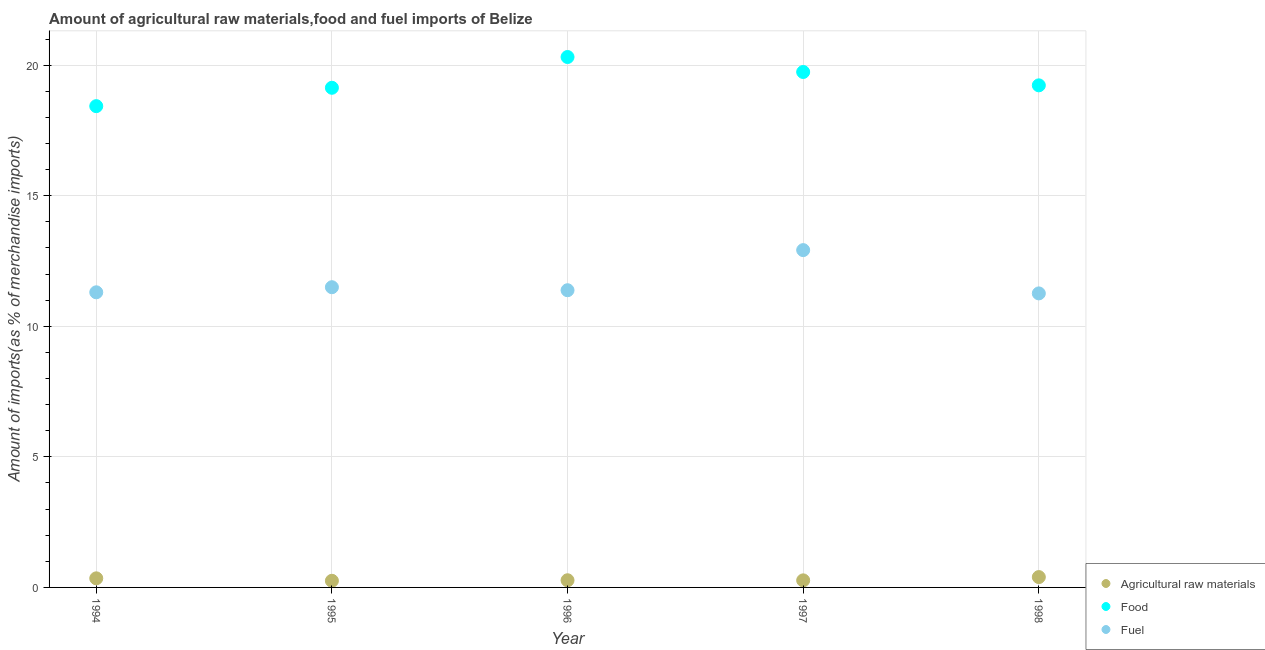What is the percentage of raw materials imports in 1998?
Offer a very short reply. 0.4. Across all years, what is the maximum percentage of food imports?
Provide a succinct answer. 20.31. Across all years, what is the minimum percentage of raw materials imports?
Your response must be concise. 0.25. In which year was the percentage of fuel imports maximum?
Your answer should be compact. 1997. What is the total percentage of fuel imports in the graph?
Your answer should be compact. 58.35. What is the difference between the percentage of food imports in 1995 and that in 1996?
Provide a short and direct response. -1.18. What is the difference between the percentage of food imports in 1994 and the percentage of fuel imports in 1995?
Your answer should be compact. 6.93. What is the average percentage of food imports per year?
Provide a short and direct response. 19.37. In the year 1998, what is the difference between the percentage of raw materials imports and percentage of food imports?
Make the answer very short. -18.83. In how many years, is the percentage of raw materials imports greater than 12 %?
Offer a very short reply. 0. What is the ratio of the percentage of fuel imports in 1996 to that in 1997?
Keep it short and to the point. 0.88. Is the percentage of raw materials imports in 1994 less than that in 1995?
Your answer should be compact. No. What is the difference between the highest and the second highest percentage of food imports?
Keep it short and to the point. 0.57. What is the difference between the highest and the lowest percentage of fuel imports?
Offer a terse response. 1.66. In how many years, is the percentage of fuel imports greater than the average percentage of fuel imports taken over all years?
Give a very brief answer. 1. Is the percentage of food imports strictly greater than the percentage of fuel imports over the years?
Your response must be concise. Yes. How many years are there in the graph?
Keep it short and to the point. 5. What is the difference between two consecutive major ticks on the Y-axis?
Ensure brevity in your answer.  5. Are the values on the major ticks of Y-axis written in scientific E-notation?
Your answer should be very brief. No. Does the graph contain any zero values?
Your answer should be very brief. No. Where does the legend appear in the graph?
Keep it short and to the point. Bottom right. How are the legend labels stacked?
Offer a terse response. Vertical. What is the title of the graph?
Make the answer very short. Amount of agricultural raw materials,food and fuel imports of Belize. What is the label or title of the X-axis?
Provide a short and direct response. Year. What is the label or title of the Y-axis?
Offer a terse response. Amount of imports(as % of merchandise imports). What is the Amount of imports(as % of merchandise imports) of Agricultural raw materials in 1994?
Offer a terse response. 0.35. What is the Amount of imports(as % of merchandise imports) of Food in 1994?
Your response must be concise. 18.43. What is the Amount of imports(as % of merchandise imports) in Fuel in 1994?
Your answer should be very brief. 11.3. What is the Amount of imports(as % of merchandise imports) of Agricultural raw materials in 1995?
Offer a very short reply. 0.25. What is the Amount of imports(as % of merchandise imports) in Food in 1995?
Give a very brief answer. 19.13. What is the Amount of imports(as % of merchandise imports) in Fuel in 1995?
Ensure brevity in your answer.  11.5. What is the Amount of imports(as % of merchandise imports) of Agricultural raw materials in 1996?
Offer a very short reply. 0.27. What is the Amount of imports(as % of merchandise imports) in Food in 1996?
Your response must be concise. 20.31. What is the Amount of imports(as % of merchandise imports) of Fuel in 1996?
Offer a very short reply. 11.38. What is the Amount of imports(as % of merchandise imports) of Agricultural raw materials in 1997?
Your answer should be very brief. 0.27. What is the Amount of imports(as % of merchandise imports) of Food in 1997?
Your answer should be very brief. 19.74. What is the Amount of imports(as % of merchandise imports) of Fuel in 1997?
Offer a very short reply. 12.92. What is the Amount of imports(as % of merchandise imports) in Agricultural raw materials in 1998?
Give a very brief answer. 0.4. What is the Amount of imports(as % of merchandise imports) in Food in 1998?
Your response must be concise. 19.23. What is the Amount of imports(as % of merchandise imports) of Fuel in 1998?
Make the answer very short. 11.26. Across all years, what is the maximum Amount of imports(as % of merchandise imports) of Agricultural raw materials?
Provide a short and direct response. 0.4. Across all years, what is the maximum Amount of imports(as % of merchandise imports) in Food?
Give a very brief answer. 20.31. Across all years, what is the maximum Amount of imports(as % of merchandise imports) of Fuel?
Offer a terse response. 12.92. Across all years, what is the minimum Amount of imports(as % of merchandise imports) in Agricultural raw materials?
Give a very brief answer. 0.25. Across all years, what is the minimum Amount of imports(as % of merchandise imports) in Food?
Keep it short and to the point. 18.43. Across all years, what is the minimum Amount of imports(as % of merchandise imports) in Fuel?
Offer a terse response. 11.26. What is the total Amount of imports(as % of merchandise imports) of Agricultural raw materials in the graph?
Provide a succinct answer. 1.54. What is the total Amount of imports(as % of merchandise imports) in Food in the graph?
Make the answer very short. 96.84. What is the total Amount of imports(as % of merchandise imports) in Fuel in the graph?
Your answer should be very brief. 58.35. What is the difference between the Amount of imports(as % of merchandise imports) of Agricultural raw materials in 1994 and that in 1995?
Keep it short and to the point. 0.09. What is the difference between the Amount of imports(as % of merchandise imports) of Food in 1994 and that in 1995?
Keep it short and to the point. -0.7. What is the difference between the Amount of imports(as % of merchandise imports) in Fuel in 1994 and that in 1995?
Make the answer very short. -0.19. What is the difference between the Amount of imports(as % of merchandise imports) of Agricultural raw materials in 1994 and that in 1996?
Your answer should be very brief. 0.07. What is the difference between the Amount of imports(as % of merchandise imports) of Food in 1994 and that in 1996?
Keep it short and to the point. -1.88. What is the difference between the Amount of imports(as % of merchandise imports) of Fuel in 1994 and that in 1996?
Make the answer very short. -0.08. What is the difference between the Amount of imports(as % of merchandise imports) of Agricultural raw materials in 1994 and that in 1997?
Keep it short and to the point. 0.08. What is the difference between the Amount of imports(as % of merchandise imports) in Food in 1994 and that in 1997?
Keep it short and to the point. -1.31. What is the difference between the Amount of imports(as % of merchandise imports) of Fuel in 1994 and that in 1997?
Provide a short and direct response. -1.62. What is the difference between the Amount of imports(as % of merchandise imports) of Agricultural raw materials in 1994 and that in 1998?
Provide a short and direct response. -0.05. What is the difference between the Amount of imports(as % of merchandise imports) of Food in 1994 and that in 1998?
Your response must be concise. -0.8. What is the difference between the Amount of imports(as % of merchandise imports) of Fuel in 1994 and that in 1998?
Offer a terse response. 0.04. What is the difference between the Amount of imports(as % of merchandise imports) of Agricultural raw materials in 1995 and that in 1996?
Your answer should be very brief. -0.02. What is the difference between the Amount of imports(as % of merchandise imports) of Food in 1995 and that in 1996?
Keep it short and to the point. -1.18. What is the difference between the Amount of imports(as % of merchandise imports) in Fuel in 1995 and that in 1996?
Keep it short and to the point. 0.12. What is the difference between the Amount of imports(as % of merchandise imports) in Agricultural raw materials in 1995 and that in 1997?
Offer a terse response. -0.02. What is the difference between the Amount of imports(as % of merchandise imports) of Food in 1995 and that in 1997?
Your answer should be compact. -0.6. What is the difference between the Amount of imports(as % of merchandise imports) in Fuel in 1995 and that in 1997?
Provide a short and direct response. -1.42. What is the difference between the Amount of imports(as % of merchandise imports) of Agricultural raw materials in 1995 and that in 1998?
Provide a succinct answer. -0.14. What is the difference between the Amount of imports(as % of merchandise imports) in Food in 1995 and that in 1998?
Your answer should be very brief. -0.09. What is the difference between the Amount of imports(as % of merchandise imports) of Fuel in 1995 and that in 1998?
Ensure brevity in your answer.  0.24. What is the difference between the Amount of imports(as % of merchandise imports) in Agricultural raw materials in 1996 and that in 1997?
Provide a short and direct response. 0. What is the difference between the Amount of imports(as % of merchandise imports) in Food in 1996 and that in 1997?
Your response must be concise. 0.57. What is the difference between the Amount of imports(as % of merchandise imports) in Fuel in 1996 and that in 1997?
Provide a short and direct response. -1.54. What is the difference between the Amount of imports(as % of merchandise imports) of Agricultural raw materials in 1996 and that in 1998?
Ensure brevity in your answer.  -0.12. What is the difference between the Amount of imports(as % of merchandise imports) in Food in 1996 and that in 1998?
Ensure brevity in your answer.  1.08. What is the difference between the Amount of imports(as % of merchandise imports) in Fuel in 1996 and that in 1998?
Ensure brevity in your answer.  0.12. What is the difference between the Amount of imports(as % of merchandise imports) in Agricultural raw materials in 1997 and that in 1998?
Keep it short and to the point. -0.13. What is the difference between the Amount of imports(as % of merchandise imports) in Food in 1997 and that in 1998?
Offer a terse response. 0.51. What is the difference between the Amount of imports(as % of merchandise imports) in Fuel in 1997 and that in 1998?
Make the answer very short. 1.66. What is the difference between the Amount of imports(as % of merchandise imports) in Agricultural raw materials in 1994 and the Amount of imports(as % of merchandise imports) in Food in 1995?
Keep it short and to the point. -18.79. What is the difference between the Amount of imports(as % of merchandise imports) in Agricultural raw materials in 1994 and the Amount of imports(as % of merchandise imports) in Fuel in 1995?
Offer a very short reply. -11.15. What is the difference between the Amount of imports(as % of merchandise imports) in Food in 1994 and the Amount of imports(as % of merchandise imports) in Fuel in 1995?
Your answer should be very brief. 6.93. What is the difference between the Amount of imports(as % of merchandise imports) of Agricultural raw materials in 1994 and the Amount of imports(as % of merchandise imports) of Food in 1996?
Give a very brief answer. -19.96. What is the difference between the Amount of imports(as % of merchandise imports) in Agricultural raw materials in 1994 and the Amount of imports(as % of merchandise imports) in Fuel in 1996?
Provide a succinct answer. -11.03. What is the difference between the Amount of imports(as % of merchandise imports) of Food in 1994 and the Amount of imports(as % of merchandise imports) of Fuel in 1996?
Ensure brevity in your answer.  7.05. What is the difference between the Amount of imports(as % of merchandise imports) in Agricultural raw materials in 1994 and the Amount of imports(as % of merchandise imports) in Food in 1997?
Your answer should be compact. -19.39. What is the difference between the Amount of imports(as % of merchandise imports) of Agricultural raw materials in 1994 and the Amount of imports(as % of merchandise imports) of Fuel in 1997?
Offer a terse response. -12.57. What is the difference between the Amount of imports(as % of merchandise imports) in Food in 1994 and the Amount of imports(as % of merchandise imports) in Fuel in 1997?
Provide a succinct answer. 5.51. What is the difference between the Amount of imports(as % of merchandise imports) in Agricultural raw materials in 1994 and the Amount of imports(as % of merchandise imports) in Food in 1998?
Offer a very short reply. -18.88. What is the difference between the Amount of imports(as % of merchandise imports) of Agricultural raw materials in 1994 and the Amount of imports(as % of merchandise imports) of Fuel in 1998?
Your answer should be compact. -10.91. What is the difference between the Amount of imports(as % of merchandise imports) in Food in 1994 and the Amount of imports(as % of merchandise imports) in Fuel in 1998?
Your response must be concise. 7.17. What is the difference between the Amount of imports(as % of merchandise imports) in Agricultural raw materials in 1995 and the Amount of imports(as % of merchandise imports) in Food in 1996?
Your answer should be compact. -20.06. What is the difference between the Amount of imports(as % of merchandise imports) of Agricultural raw materials in 1995 and the Amount of imports(as % of merchandise imports) of Fuel in 1996?
Your answer should be compact. -11.13. What is the difference between the Amount of imports(as % of merchandise imports) in Food in 1995 and the Amount of imports(as % of merchandise imports) in Fuel in 1996?
Make the answer very short. 7.75. What is the difference between the Amount of imports(as % of merchandise imports) in Agricultural raw materials in 1995 and the Amount of imports(as % of merchandise imports) in Food in 1997?
Offer a very short reply. -19.48. What is the difference between the Amount of imports(as % of merchandise imports) in Agricultural raw materials in 1995 and the Amount of imports(as % of merchandise imports) in Fuel in 1997?
Provide a succinct answer. -12.66. What is the difference between the Amount of imports(as % of merchandise imports) of Food in 1995 and the Amount of imports(as % of merchandise imports) of Fuel in 1997?
Give a very brief answer. 6.22. What is the difference between the Amount of imports(as % of merchandise imports) of Agricultural raw materials in 1995 and the Amount of imports(as % of merchandise imports) of Food in 1998?
Make the answer very short. -18.97. What is the difference between the Amount of imports(as % of merchandise imports) of Agricultural raw materials in 1995 and the Amount of imports(as % of merchandise imports) of Fuel in 1998?
Your response must be concise. -11.01. What is the difference between the Amount of imports(as % of merchandise imports) of Food in 1995 and the Amount of imports(as % of merchandise imports) of Fuel in 1998?
Offer a terse response. 7.87. What is the difference between the Amount of imports(as % of merchandise imports) of Agricultural raw materials in 1996 and the Amount of imports(as % of merchandise imports) of Food in 1997?
Keep it short and to the point. -19.46. What is the difference between the Amount of imports(as % of merchandise imports) in Agricultural raw materials in 1996 and the Amount of imports(as % of merchandise imports) in Fuel in 1997?
Offer a terse response. -12.64. What is the difference between the Amount of imports(as % of merchandise imports) in Food in 1996 and the Amount of imports(as % of merchandise imports) in Fuel in 1997?
Give a very brief answer. 7.39. What is the difference between the Amount of imports(as % of merchandise imports) in Agricultural raw materials in 1996 and the Amount of imports(as % of merchandise imports) in Food in 1998?
Keep it short and to the point. -18.95. What is the difference between the Amount of imports(as % of merchandise imports) of Agricultural raw materials in 1996 and the Amount of imports(as % of merchandise imports) of Fuel in 1998?
Offer a very short reply. -10.98. What is the difference between the Amount of imports(as % of merchandise imports) in Food in 1996 and the Amount of imports(as % of merchandise imports) in Fuel in 1998?
Your response must be concise. 9.05. What is the difference between the Amount of imports(as % of merchandise imports) of Agricultural raw materials in 1997 and the Amount of imports(as % of merchandise imports) of Food in 1998?
Keep it short and to the point. -18.96. What is the difference between the Amount of imports(as % of merchandise imports) of Agricultural raw materials in 1997 and the Amount of imports(as % of merchandise imports) of Fuel in 1998?
Offer a terse response. -10.99. What is the difference between the Amount of imports(as % of merchandise imports) of Food in 1997 and the Amount of imports(as % of merchandise imports) of Fuel in 1998?
Your answer should be compact. 8.48. What is the average Amount of imports(as % of merchandise imports) in Agricultural raw materials per year?
Your response must be concise. 0.31. What is the average Amount of imports(as % of merchandise imports) in Food per year?
Provide a short and direct response. 19.37. What is the average Amount of imports(as % of merchandise imports) of Fuel per year?
Give a very brief answer. 11.67. In the year 1994, what is the difference between the Amount of imports(as % of merchandise imports) of Agricultural raw materials and Amount of imports(as % of merchandise imports) of Food?
Provide a succinct answer. -18.08. In the year 1994, what is the difference between the Amount of imports(as % of merchandise imports) in Agricultural raw materials and Amount of imports(as % of merchandise imports) in Fuel?
Your answer should be compact. -10.95. In the year 1994, what is the difference between the Amount of imports(as % of merchandise imports) in Food and Amount of imports(as % of merchandise imports) in Fuel?
Provide a succinct answer. 7.13. In the year 1995, what is the difference between the Amount of imports(as % of merchandise imports) in Agricultural raw materials and Amount of imports(as % of merchandise imports) in Food?
Give a very brief answer. -18.88. In the year 1995, what is the difference between the Amount of imports(as % of merchandise imports) of Agricultural raw materials and Amount of imports(as % of merchandise imports) of Fuel?
Your answer should be compact. -11.24. In the year 1995, what is the difference between the Amount of imports(as % of merchandise imports) in Food and Amount of imports(as % of merchandise imports) in Fuel?
Offer a very short reply. 7.64. In the year 1996, what is the difference between the Amount of imports(as % of merchandise imports) in Agricultural raw materials and Amount of imports(as % of merchandise imports) in Food?
Keep it short and to the point. -20.04. In the year 1996, what is the difference between the Amount of imports(as % of merchandise imports) in Agricultural raw materials and Amount of imports(as % of merchandise imports) in Fuel?
Provide a short and direct response. -11.11. In the year 1996, what is the difference between the Amount of imports(as % of merchandise imports) of Food and Amount of imports(as % of merchandise imports) of Fuel?
Provide a short and direct response. 8.93. In the year 1997, what is the difference between the Amount of imports(as % of merchandise imports) of Agricultural raw materials and Amount of imports(as % of merchandise imports) of Food?
Give a very brief answer. -19.47. In the year 1997, what is the difference between the Amount of imports(as % of merchandise imports) of Agricultural raw materials and Amount of imports(as % of merchandise imports) of Fuel?
Ensure brevity in your answer.  -12.65. In the year 1997, what is the difference between the Amount of imports(as % of merchandise imports) in Food and Amount of imports(as % of merchandise imports) in Fuel?
Your answer should be very brief. 6.82. In the year 1998, what is the difference between the Amount of imports(as % of merchandise imports) in Agricultural raw materials and Amount of imports(as % of merchandise imports) in Food?
Offer a very short reply. -18.83. In the year 1998, what is the difference between the Amount of imports(as % of merchandise imports) of Agricultural raw materials and Amount of imports(as % of merchandise imports) of Fuel?
Offer a terse response. -10.86. In the year 1998, what is the difference between the Amount of imports(as % of merchandise imports) of Food and Amount of imports(as % of merchandise imports) of Fuel?
Keep it short and to the point. 7.97. What is the ratio of the Amount of imports(as % of merchandise imports) of Agricultural raw materials in 1994 to that in 1995?
Your answer should be very brief. 1.37. What is the ratio of the Amount of imports(as % of merchandise imports) in Food in 1994 to that in 1995?
Offer a terse response. 0.96. What is the ratio of the Amount of imports(as % of merchandise imports) in Fuel in 1994 to that in 1995?
Ensure brevity in your answer.  0.98. What is the ratio of the Amount of imports(as % of merchandise imports) of Agricultural raw materials in 1994 to that in 1996?
Your response must be concise. 1.27. What is the ratio of the Amount of imports(as % of merchandise imports) in Food in 1994 to that in 1996?
Give a very brief answer. 0.91. What is the ratio of the Amount of imports(as % of merchandise imports) of Fuel in 1994 to that in 1996?
Keep it short and to the point. 0.99. What is the ratio of the Amount of imports(as % of merchandise imports) in Agricultural raw materials in 1994 to that in 1997?
Ensure brevity in your answer.  1.29. What is the ratio of the Amount of imports(as % of merchandise imports) in Food in 1994 to that in 1997?
Your response must be concise. 0.93. What is the ratio of the Amount of imports(as % of merchandise imports) in Fuel in 1994 to that in 1997?
Keep it short and to the point. 0.87. What is the ratio of the Amount of imports(as % of merchandise imports) of Agricultural raw materials in 1994 to that in 1998?
Keep it short and to the point. 0.88. What is the ratio of the Amount of imports(as % of merchandise imports) of Food in 1994 to that in 1998?
Your response must be concise. 0.96. What is the ratio of the Amount of imports(as % of merchandise imports) of Fuel in 1994 to that in 1998?
Provide a short and direct response. 1. What is the ratio of the Amount of imports(as % of merchandise imports) in Agricultural raw materials in 1995 to that in 1996?
Your answer should be compact. 0.92. What is the ratio of the Amount of imports(as % of merchandise imports) of Food in 1995 to that in 1996?
Give a very brief answer. 0.94. What is the ratio of the Amount of imports(as % of merchandise imports) of Agricultural raw materials in 1995 to that in 1997?
Offer a very short reply. 0.94. What is the ratio of the Amount of imports(as % of merchandise imports) of Food in 1995 to that in 1997?
Your answer should be very brief. 0.97. What is the ratio of the Amount of imports(as % of merchandise imports) of Fuel in 1995 to that in 1997?
Offer a very short reply. 0.89. What is the ratio of the Amount of imports(as % of merchandise imports) in Agricultural raw materials in 1995 to that in 1998?
Provide a short and direct response. 0.64. What is the ratio of the Amount of imports(as % of merchandise imports) of Food in 1996 to that in 1997?
Your answer should be very brief. 1.03. What is the ratio of the Amount of imports(as % of merchandise imports) in Fuel in 1996 to that in 1997?
Your answer should be compact. 0.88. What is the ratio of the Amount of imports(as % of merchandise imports) of Agricultural raw materials in 1996 to that in 1998?
Offer a terse response. 0.69. What is the ratio of the Amount of imports(as % of merchandise imports) in Food in 1996 to that in 1998?
Provide a succinct answer. 1.06. What is the ratio of the Amount of imports(as % of merchandise imports) of Fuel in 1996 to that in 1998?
Your response must be concise. 1.01. What is the ratio of the Amount of imports(as % of merchandise imports) in Agricultural raw materials in 1997 to that in 1998?
Keep it short and to the point. 0.68. What is the ratio of the Amount of imports(as % of merchandise imports) of Food in 1997 to that in 1998?
Offer a terse response. 1.03. What is the ratio of the Amount of imports(as % of merchandise imports) in Fuel in 1997 to that in 1998?
Provide a short and direct response. 1.15. What is the difference between the highest and the second highest Amount of imports(as % of merchandise imports) of Agricultural raw materials?
Provide a short and direct response. 0.05. What is the difference between the highest and the second highest Amount of imports(as % of merchandise imports) in Food?
Your response must be concise. 0.57. What is the difference between the highest and the second highest Amount of imports(as % of merchandise imports) of Fuel?
Make the answer very short. 1.42. What is the difference between the highest and the lowest Amount of imports(as % of merchandise imports) in Agricultural raw materials?
Give a very brief answer. 0.14. What is the difference between the highest and the lowest Amount of imports(as % of merchandise imports) of Food?
Give a very brief answer. 1.88. What is the difference between the highest and the lowest Amount of imports(as % of merchandise imports) of Fuel?
Your answer should be very brief. 1.66. 